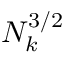<formula> <loc_0><loc_0><loc_500><loc_500>N _ { k } ^ { 3 / 2 }</formula> 